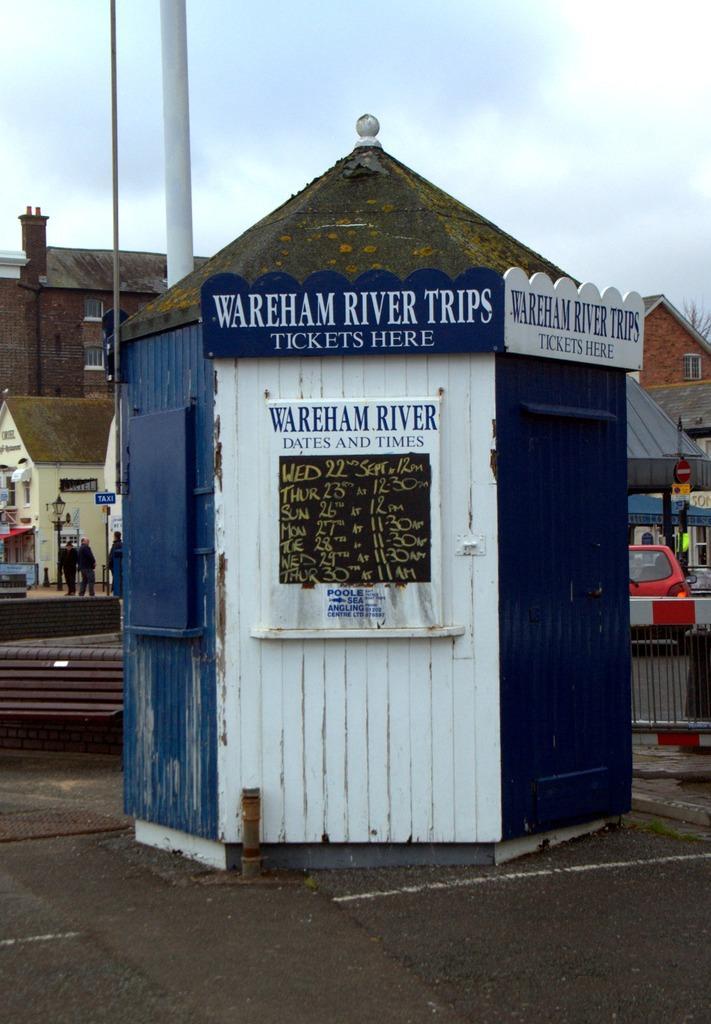Could you give a brief overview of what you see in this image? In this image there is a house having few boards attached to it. Few persons are standing on the floor. Right side there is a car on the road. Before it there is a fence. A street light is on the pavement. Background there are few buildings. Top of the image there is sky. Behind the house there is a pole. 